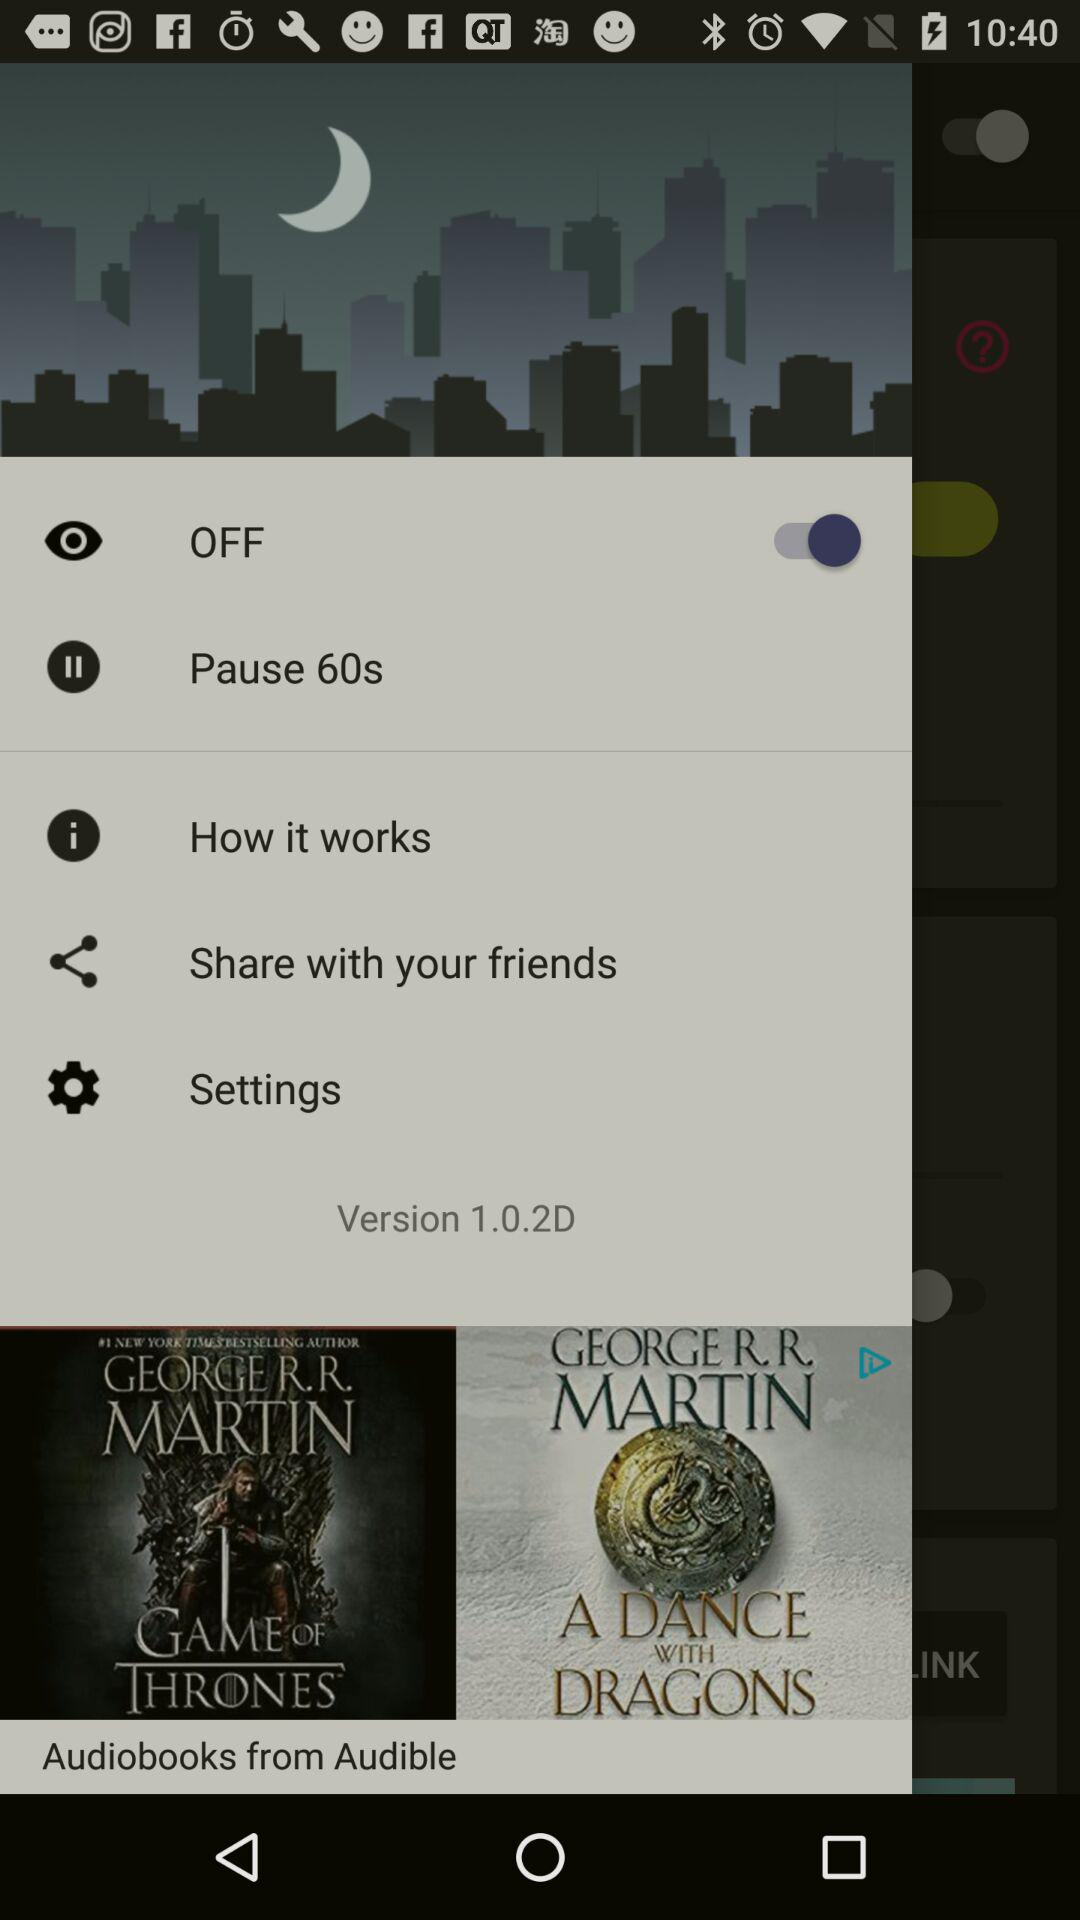Can we share it with anyone? Yes, you can share it with your friends. 